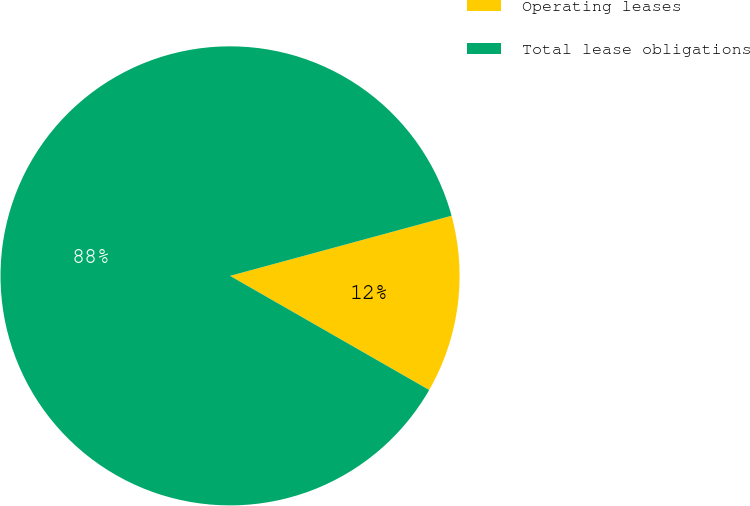Convert chart to OTSL. <chart><loc_0><loc_0><loc_500><loc_500><pie_chart><fcel>Operating leases<fcel>Total lease obligations<nl><fcel>12.5%<fcel>87.5%<nl></chart> 